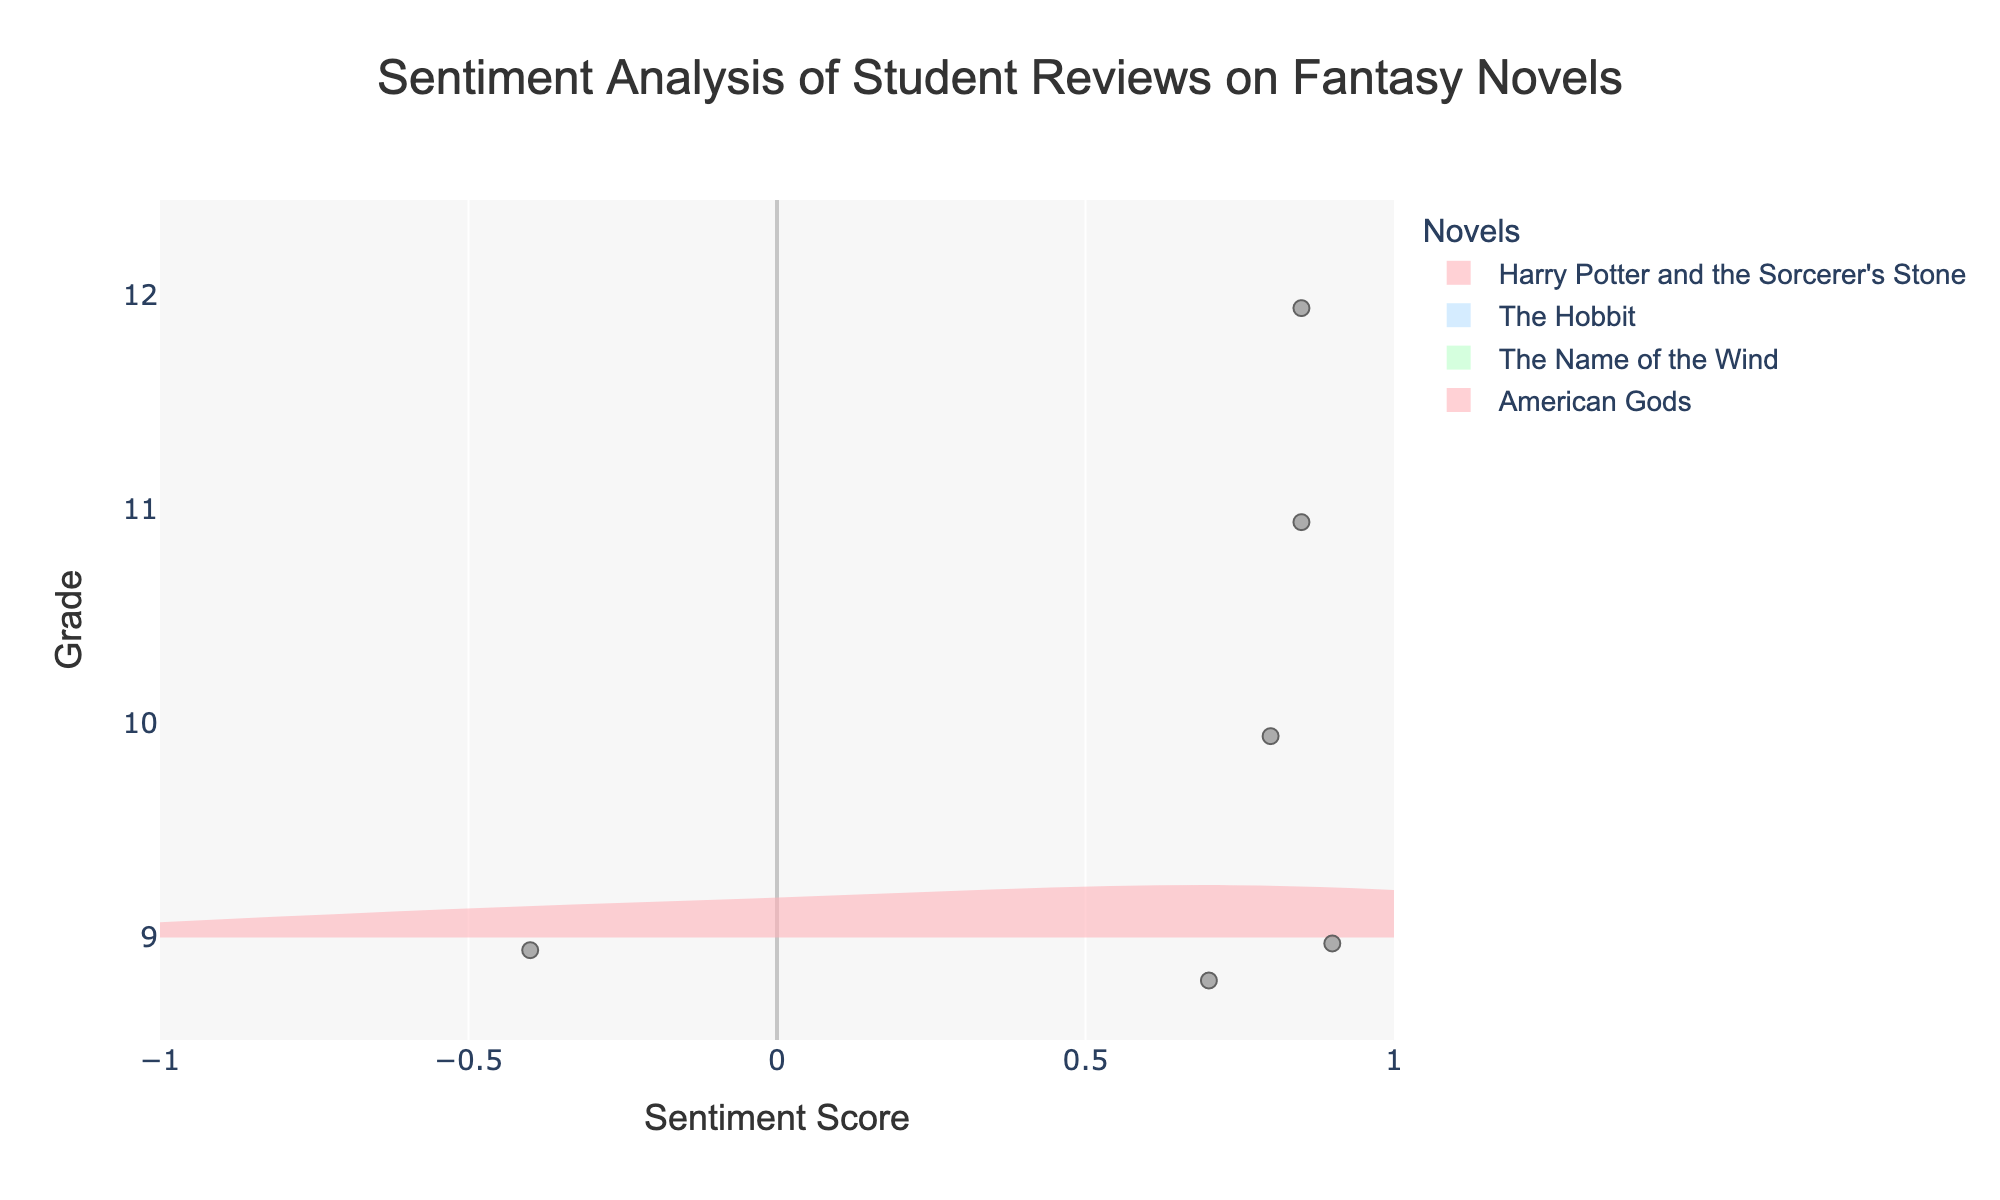Which grade has the highest positive sentiment score for "Harry Potter and the Sorcerer's Stone"? To determine this, look for the highest point on the violin plot for "Harry Potter and the Sorcerer's Stone" in the 9th grade. The highest sentiment score is 0.9.
Answer: 9th grade What is the range of sentiment scores for "The Hobbit"? The range is determined by finding the minimum and maximum sentiment scores on the violin plot for "The Hobbit," which ranges from 0.8 to 0.8.
Answer: 0.8 How do the sentiment scores for "The Name of the Wind" compare across different grade levels? Check the violin plot for "The Name of the Wind," assigned to the 11th grade. Observe the spread and central tendency of the sentiment scores. In this case, it shows a strong, positive sentiment centered around 0.85.
Answer: Strong, positive sentiment for 11th grade Which novel has the most varied sentiment scores in the 9th grade? For the 9th grade, compare the spread of the sentiment scores in the violin plots for "Harry Potter and the Sorcerer's Stone." A larger spread indicates more variation in sentiment. "Harry Potter and the Sorcerer's Stone" shows a wide range from -0.4 to 0.9.
Answer: "Harry Potter and the Sorcerer's Stone" Is there a novel with uniformly positive sentiment scores in the higher grades (10 to 12)? Look at the sentiment scores for higher grades (10 to 12) and see if the violin plots only show positive scores. "The Hobbit" for 10th grade and "American Gods" for 12th grade both display uniformly positive sentiment scores around 0.8 and 0.85, respectively.
Answer: "The Hobbit" and "American Gods" What is the mean sentiment score for "Harry Potter and the Sorcerer's Stone" in the 9th grade? Observe the meanline in the violin plot for "Harry Potter and the Sorcerer's Stone" under the 9th grade to find the average sentiment score. The mean line is at approximately 0.4.
Answer: 0.4 Which novel appears to be the most consistently enjoyed across the grades? Look for the violin plots with the smallest spread and highest averages across grades. "The Name of the Wind" for 11th grade and "American Gods" for 12th grade have consistently high positive scores without wide variability.
Answer: "The Name of the Wind" and "American Gods" What is the sentiment score distribution for "American Gods" assigned to the 12th grade? Find the violin plot for "American Gods." The distribution shows scores clustered tightly around 0.85 with little variation.
Answer: Around 0.85 tightly clustered 